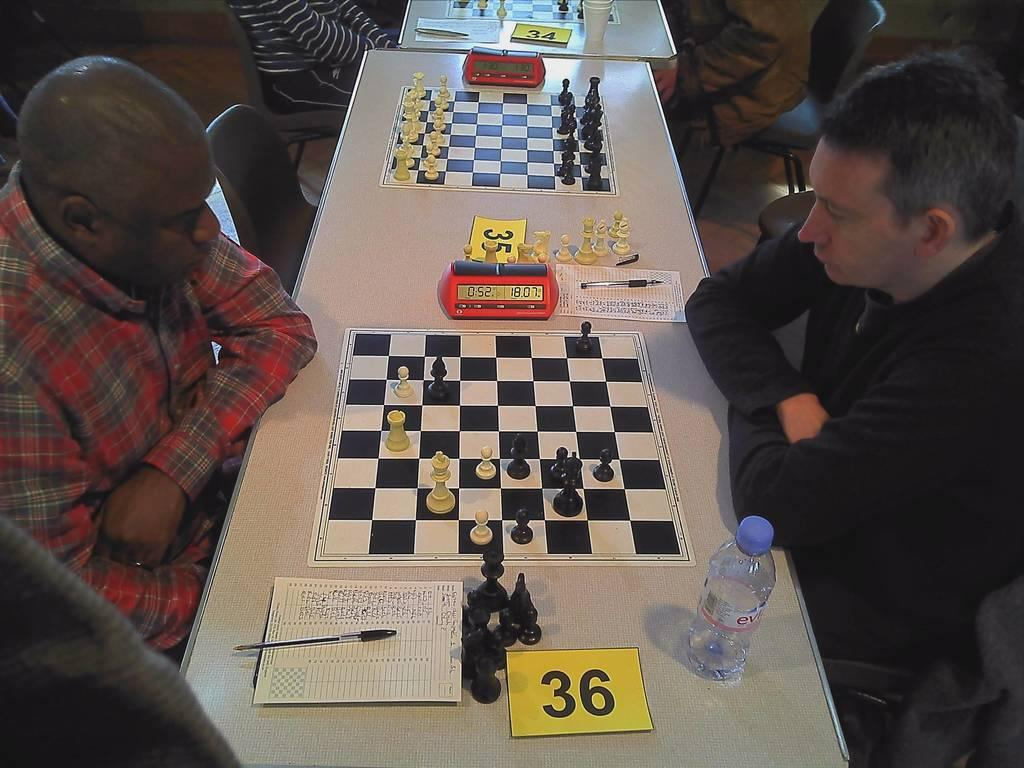What activity are the people in the image engaged in? The people in the image are playing chess. What is the main object on which the game is being played? There is a chess board on the table. What other items can be seen on the table? There is a pen, a piece of paper, and a water bottle on the table. Can you touch the wall in the image? There is no wall present in the image; it only shows people playing chess on a table. What type of milk is being used in the game? There is no milk present in the image; it only shows people playing chess with a chess board, pen, paper, and water bottle on the table. 